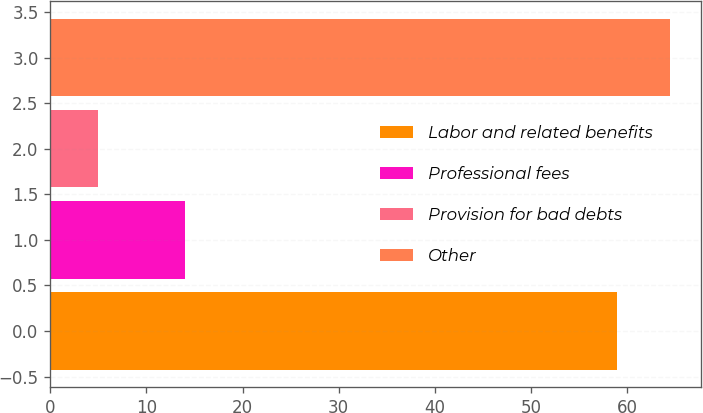Convert chart. <chart><loc_0><loc_0><loc_500><loc_500><bar_chart><fcel>Labor and related benefits<fcel>Professional fees<fcel>Provision for bad debts<fcel>Other<nl><fcel>59<fcel>14<fcel>5<fcel>64.5<nl></chart> 